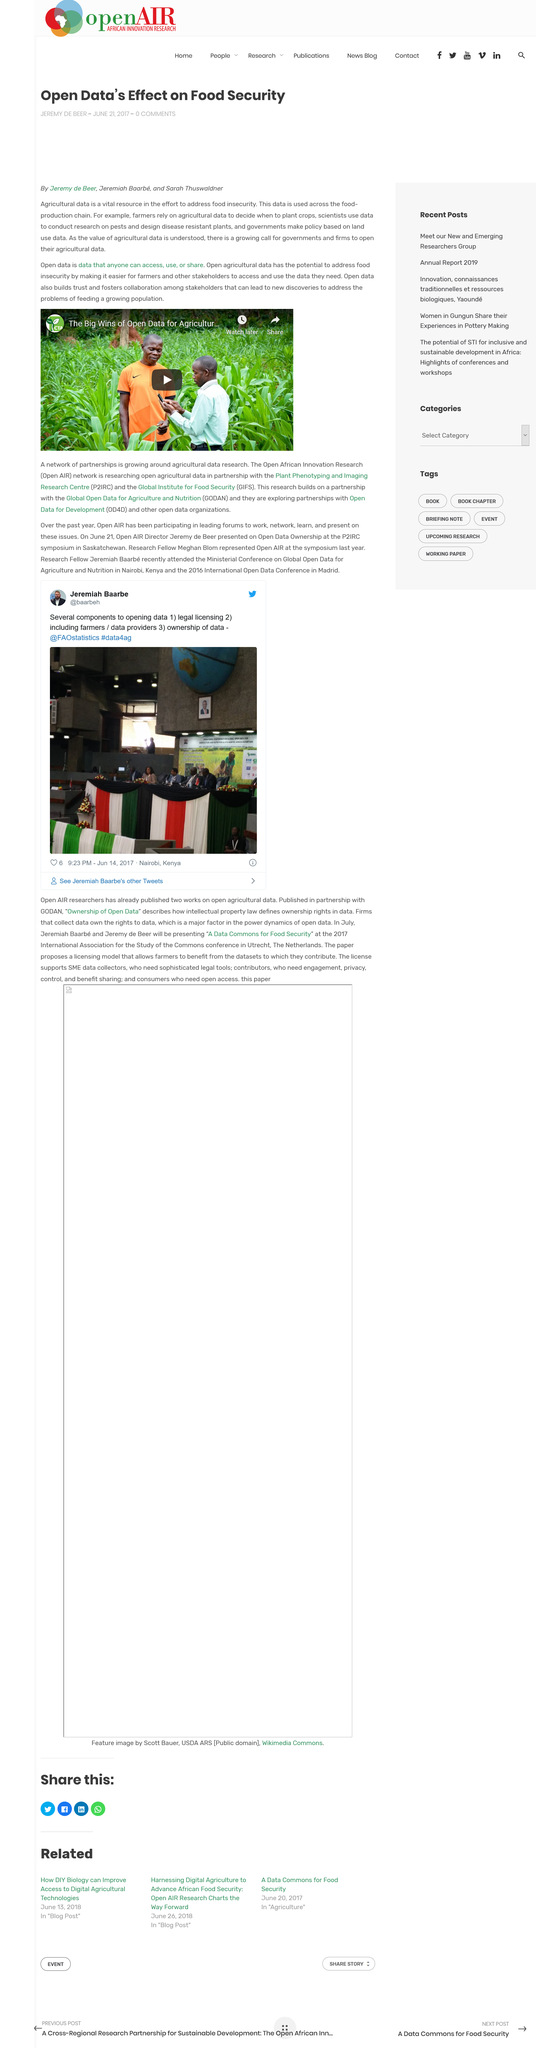Draw attention to some important aspects in this diagram. The author of this article is Jeremy de Beer. Open agricultural data has the potential to address food insecurity by making it easier for farmers and other stakeholders to access and use the data they need, which can ultimately lead to more efficient and sustainable agricultural practices, and improved food security for communities globally. Open data is defined as data that is freely available to anyone for access, use, or sharing. 